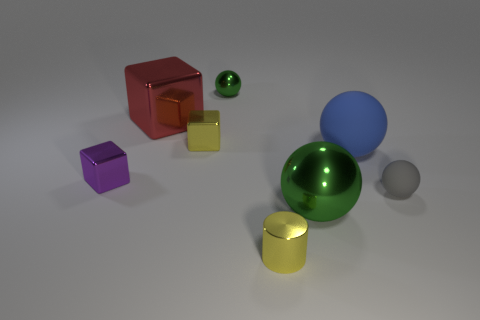There is a metallic object that is the same color as the shiny cylinder; what shape is it?
Make the answer very short. Cube. Does the small green sphere have the same material as the big green ball behind the metal cylinder?
Keep it short and to the point. Yes. The red metal thing that is the same shape as the tiny purple metallic object is what size?
Your response must be concise. Large. Are there the same number of tiny gray objects that are behind the tiny green shiny thing and small cylinders on the left side of the tiny yellow metal block?
Provide a succinct answer. Yes. What number of other things are there of the same material as the small yellow cube
Provide a short and direct response. 5. Are there the same number of blocks behind the large blue object and large green things?
Your response must be concise. No. Do the blue sphere and the green metallic ball that is behind the small rubber ball have the same size?
Your answer should be very brief. No. What is the shape of the large metallic object in front of the yellow block?
Offer a terse response. Sphere. Are any tiny green balls visible?
Provide a short and direct response. Yes. There is a yellow thing behind the purple block; is its size the same as the shiny ball behind the small gray matte sphere?
Your response must be concise. Yes. 